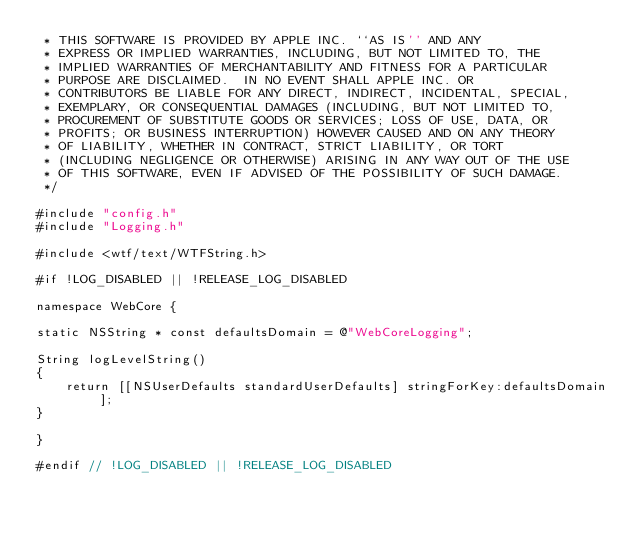<code> <loc_0><loc_0><loc_500><loc_500><_ObjectiveC_> * THIS SOFTWARE IS PROVIDED BY APPLE INC. ``AS IS'' AND ANY
 * EXPRESS OR IMPLIED WARRANTIES, INCLUDING, BUT NOT LIMITED TO, THE
 * IMPLIED WARRANTIES OF MERCHANTABILITY AND FITNESS FOR A PARTICULAR
 * PURPOSE ARE DISCLAIMED.  IN NO EVENT SHALL APPLE INC. OR
 * CONTRIBUTORS BE LIABLE FOR ANY DIRECT, INDIRECT, INCIDENTAL, SPECIAL,
 * EXEMPLARY, OR CONSEQUENTIAL DAMAGES (INCLUDING, BUT NOT LIMITED TO,
 * PROCUREMENT OF SUBSTITUTE GOODS OR SERVICES; LOSS OF USE, DATA, OR
 * PROFITS; OR BUSINESS INTERRUPTION) HOWEVER CAUSED AND ON ANY THEORY
 * OF LIABILITY, WHETHER IN CONTRACT, STRICT LIABILITY, OR TORT
 * (INCLUDING NEGLIGENCE OR OTHERWISE) ARISING IN ANY WAY OUT OF THE USE
 * OF THIS SOFTWARE, EVEN IF ADVISED OF THE POSSIBILITY OF SUCH DAMAGE. 
 */

#include "config.h"
#include "Logging.h"

#include <wtf/text/WTFString.h>

#if !LOG_DISABLED || !RELEASE_LOG_DISABLED

namespace WebCore {

static NSString * const defaultsDomain = @"WebCoreLogging";

String logLevelString()
{
    return [[NSUserDefaults standardUserDefaults] stringForKey:defaultsDomain];
}

}

#endif // !LOG_DISABLED || !RELEASE_LOG_DISABLED
</code> 